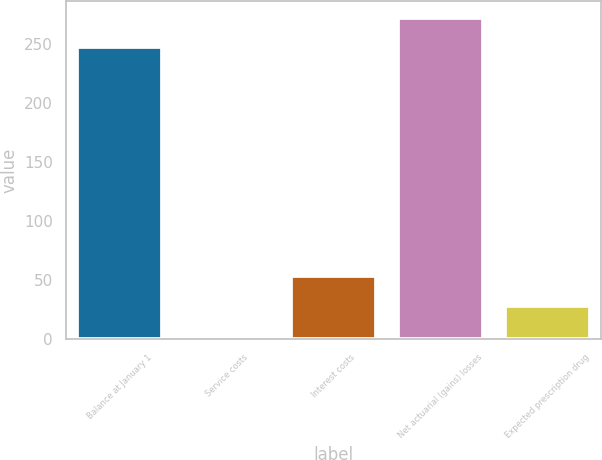Convert chart to OTSL. <chart><loc_0><loc_0><loc_500><loc_500><bar_chart><fcel>Balance at January 1<fcel>Service costs<fcel>Interest costs<fcel>Net actuarial (gains) losses<fcel>Expected prescription drug<nl><fcel>247<fcel>3<fcel>53.4<fcel>272.2<fcel>28.2<nl></chart> 